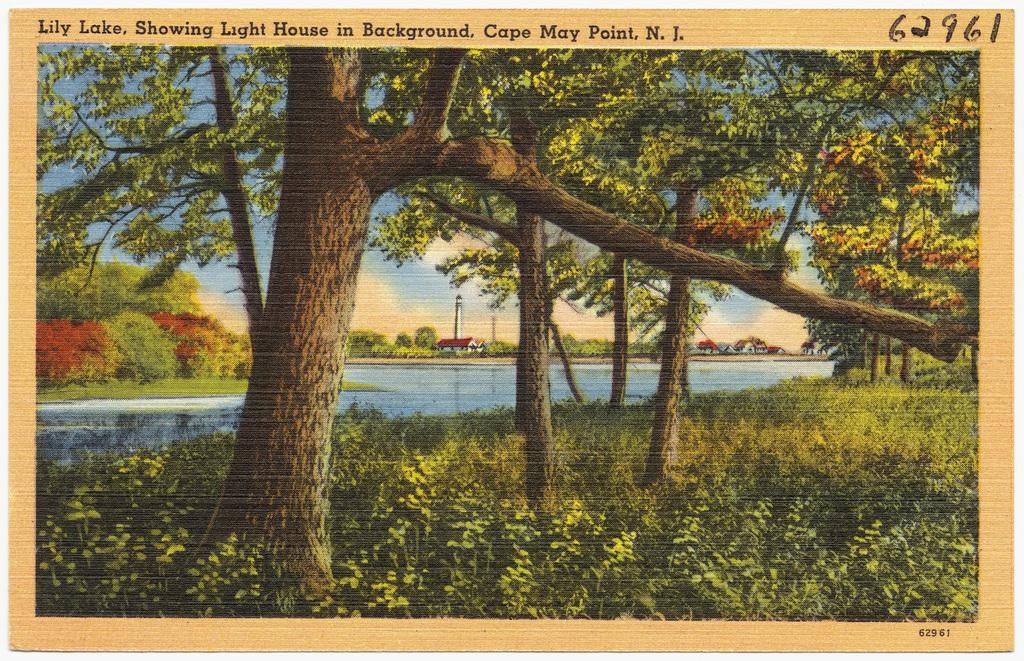What type of vegetation can be seen in the image? There are trees in the image. What natural element is also visible in the image? There is water visible in the image. What covers the ground in the image? The ground in the image is covered with plants. What type of argument is taking place in the image? There is no argument present in the image; it features trees, water, and plants. Is there a road visible in the image? There is no road present in the image. 